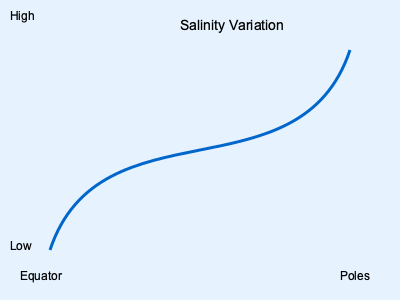As a seasoned sailor, you've likely observed differences in seawater across various ocean regions. The diagram shows the variation of a particular seawater property from the equator to the poles. What chemical component of seawater does this curve most likely represent, and what factors contribute to this distribution pattern? 1. The curve in the diagram shows a property that is higher at the equator and poles, but lower in the mid-latitudes.

2. This pattern most closely resembles the distribution of salinity in the world's oceans.

3. Factors influencing this salinity distribution:
   a) At the equator: High evaporation rates due to intense sunlight increase salinity.
   b) In mid-latitudes: Higher precipitation and river runoff decrease salinity.
   c) Near the poles: Ice formation excludes salt, increasing the salinity of surrounding water.

4. The chemical composition affected is primarily $NaCl$ (sodium chloride), the main salt in seawater.

5. The average salinity of seawater is about 35 parts per thousand (ppt), but it can range from about 33 to 37 ppt in open oceans.

6. Other factors influencing salinity include:
   - Ocean currents
   - Mixing of water masses
   - Freshwater input from melting ice in polar regions

7. Understanding salinity is crucial for marine life, as it affects osmotic pressure and the ability of organisms to maintain water balance.
Answer: Salinity, influenced by evaporation, precipitation, and ice formation. 